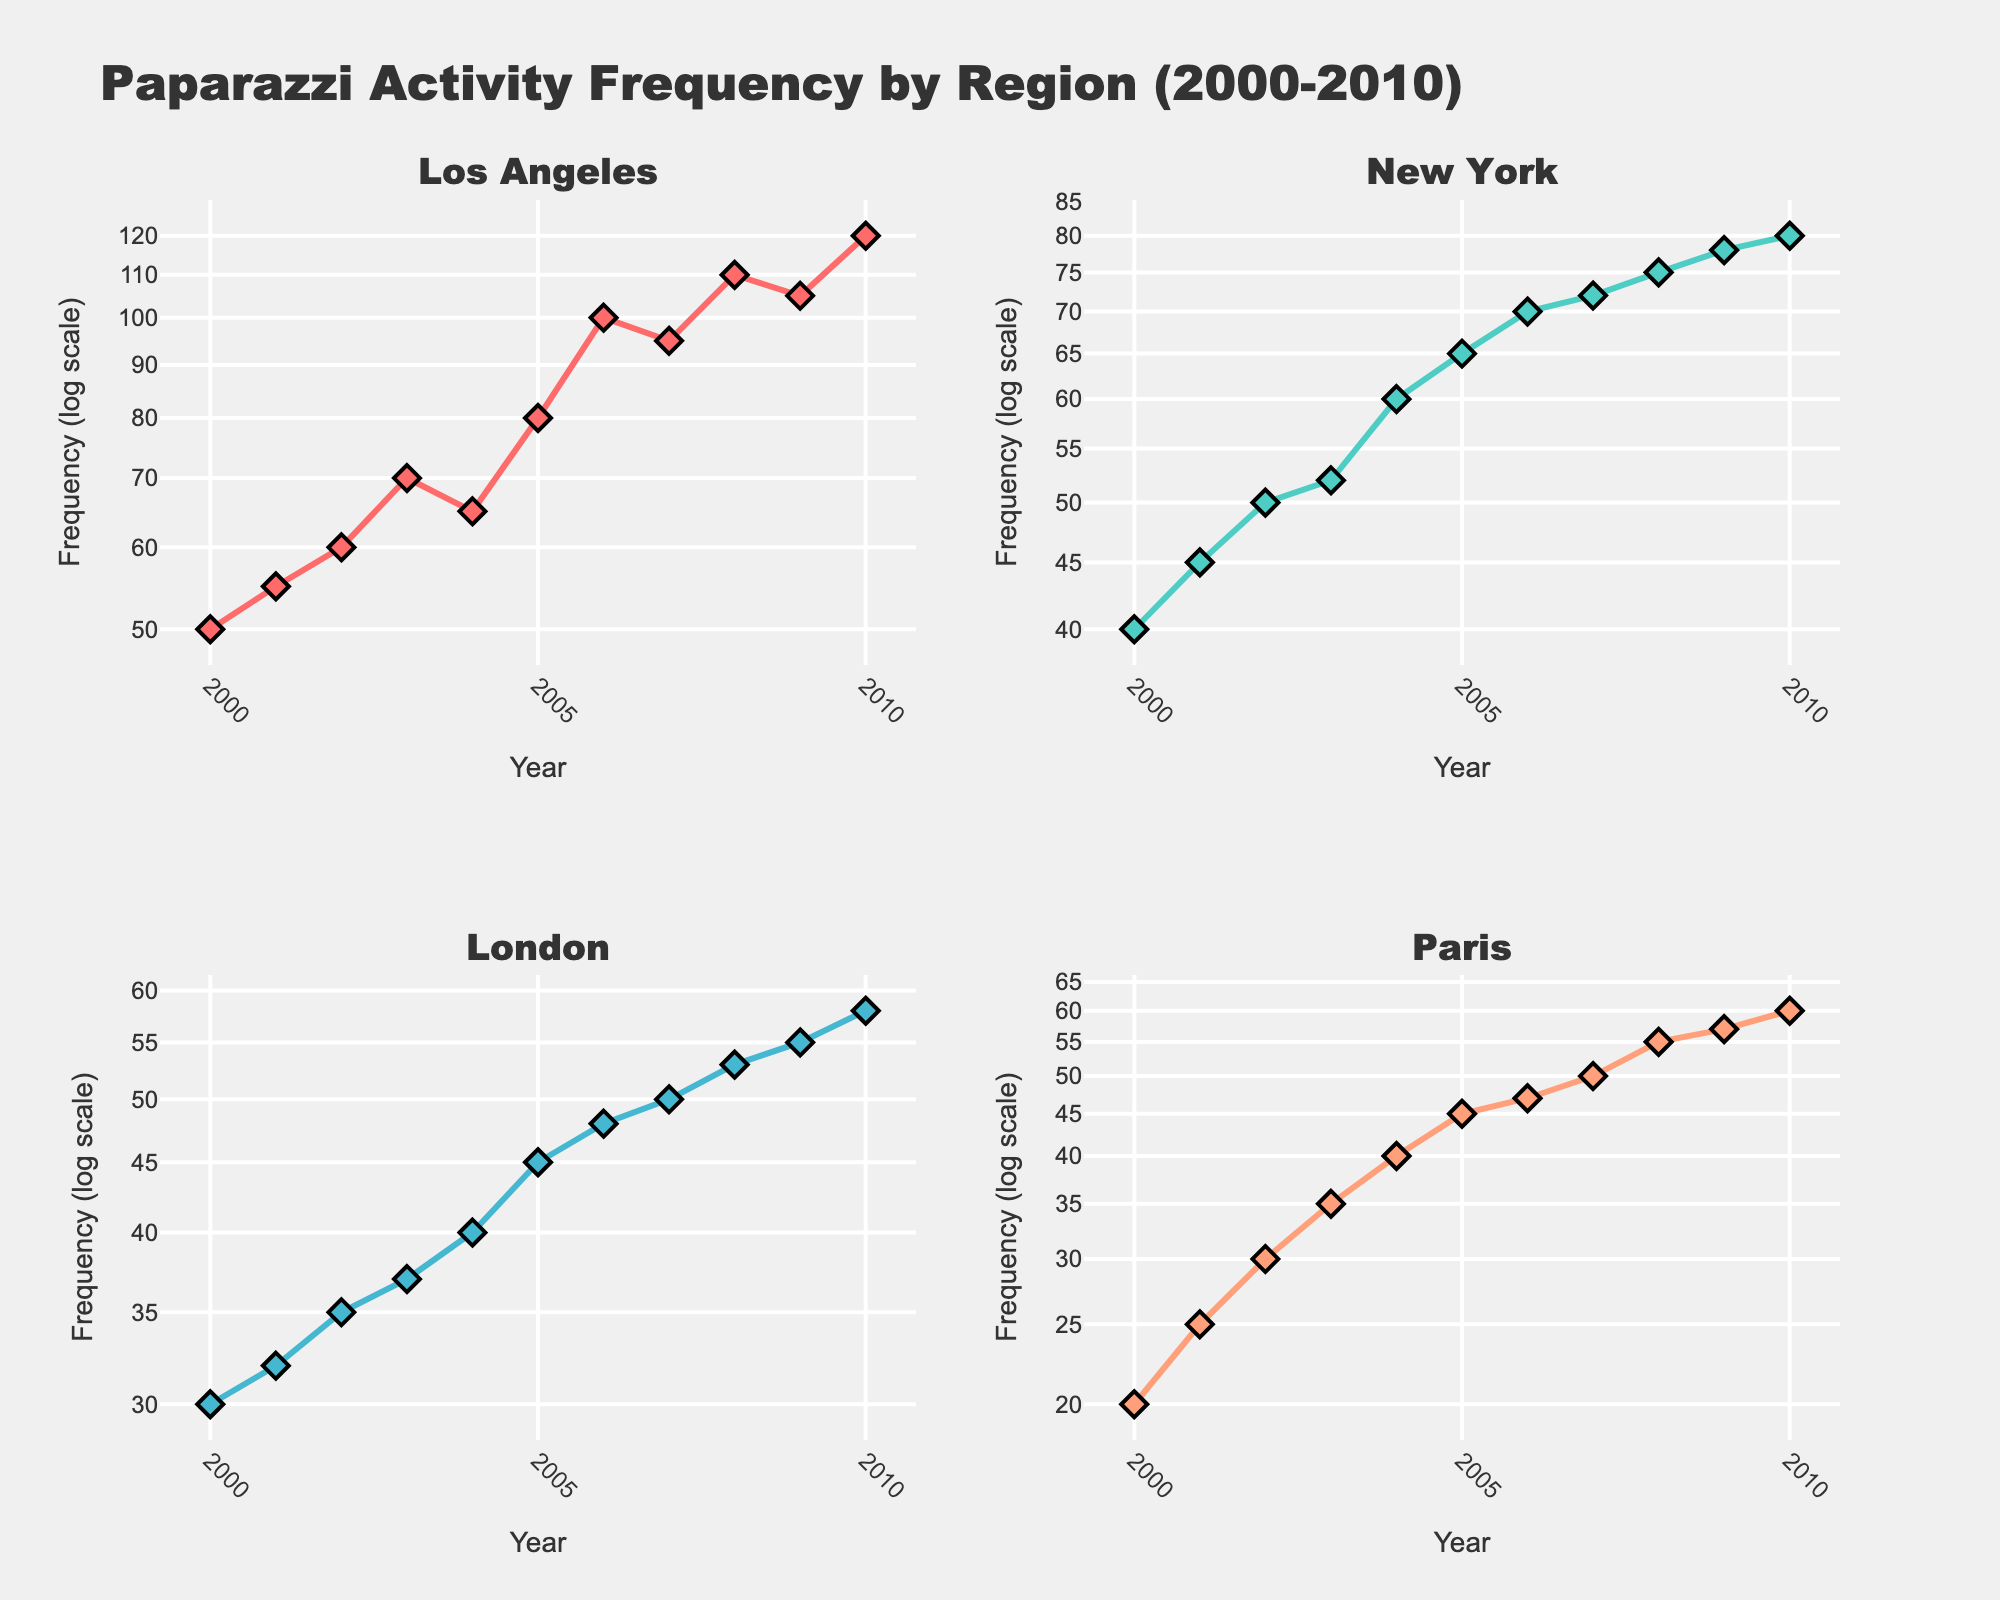What is the title of the figure? The title is usually located at the top of the figure and provides a brief description of what the figure represents. In this case, it reads "Paparazzi Activity Frequency by Region (2000-2010)".
Answer: Paparazzi Activity Frequency by Region (2000-2010) How do the Y-axes differ from typical plots? The Y-axes in this figure are set to a logarithmic scale, indicated by the exponential markings which increase multiplicatively.
Answer: Logarithmic scale Which region shows the highest frequency of paparazzi activities in 2010? By inspecting the subplot for each region, the subplot for Los Angeles shows the largest frequency value in 2010.
Answer: Los Angeles How does the trend of paparazzi activities in New York from 2000 to 2010 compare to Los Angeles? This requires observing both subplots. New York shows a steady, linear increase, while Los Angeles shows a more erratic trend with both sharp increases and decreases while generally moving upward.
Answer: New York's trend is steadier; Los Angeles is more erratic Which region had the lowest frequency of paparazzi activities in 2005? By examining the subplots and comparing the Y-values for each region in 2005, Paris had the lowest frequency.
Answer: Paris How many subplots are in the figure and what do they represent? The figure consists of 4 subplots, each representing a different region: Los Angeles, New York, London, and Paris.
Answer: 4 subplots, 4 regions What is the overall trend of paparazzi activities in London from 2000 to 2010? London's subplot shows a steady increase in paparazzi activities over the years without any sudden drops or spikes.
Answer: Steady increase Between which two consecutive years did Los Angeles see the largest increase in paparazzi activities? By looking at the vertical distances between points on the Los Angeles subplot, the largest increase occurs between 2005 and 2006.
Answer: Between 2005 and 2006 What pattern do we observe in all subplots in terms of their Y-axes setup? All subplots use a logarithmic scale for the Y-axes, as indicated by the exponential labels.
Answer: Logarithmic scale for Y-axes How do the frequencies in Paris in 2000-2010 compare with those in London? By comparing the Y-values in both subplots, it's evident that the frequencies in Paris are consistently lower than those in London throughout the period.
Answer: Paris consistently lower than London 